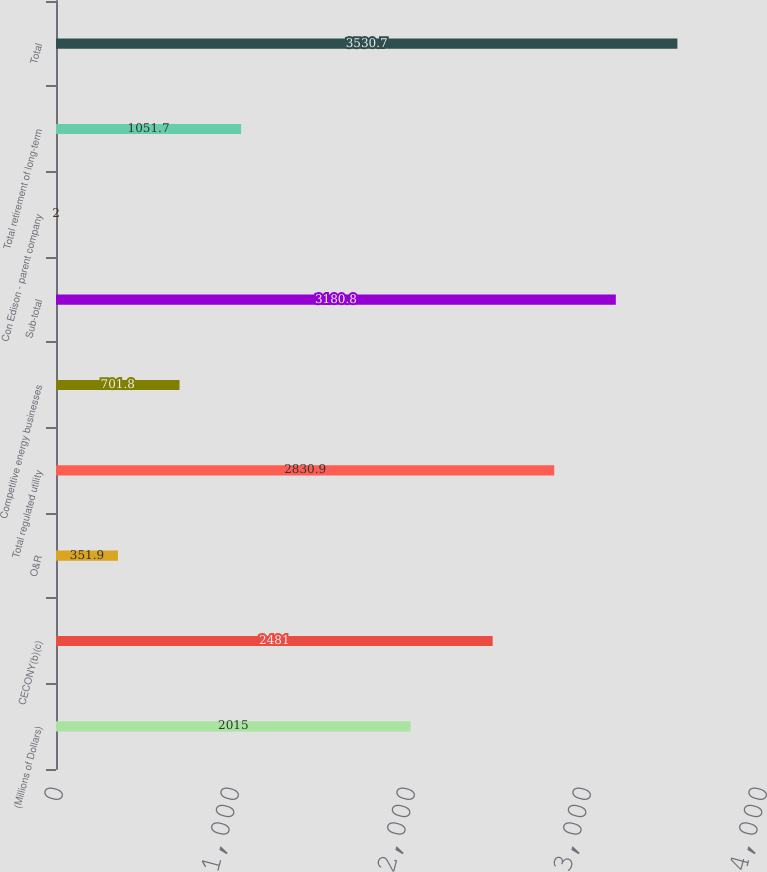Convert chart to OTSL. <chart><loc_0><loc_0><loc_500><loc_500><bar_chart><fcel>(Millions of Dollars)<fcel>CECONY(b)(c)<fcel>O&R<fcel>Total regulated utility<fcel>Competitive energy businesses<fcel>Sub-total<fcel>Con Edison - parent company<fcel>Total retirement of long-term<fcel>Total<nl><fcel>2015<fcel>2481<fcel>351.9<fcel>2830.9<fcel>701.8<fcel>3180.8<fcel>2<fcel>1051.7<fcel>3530.7<nl></chart> 